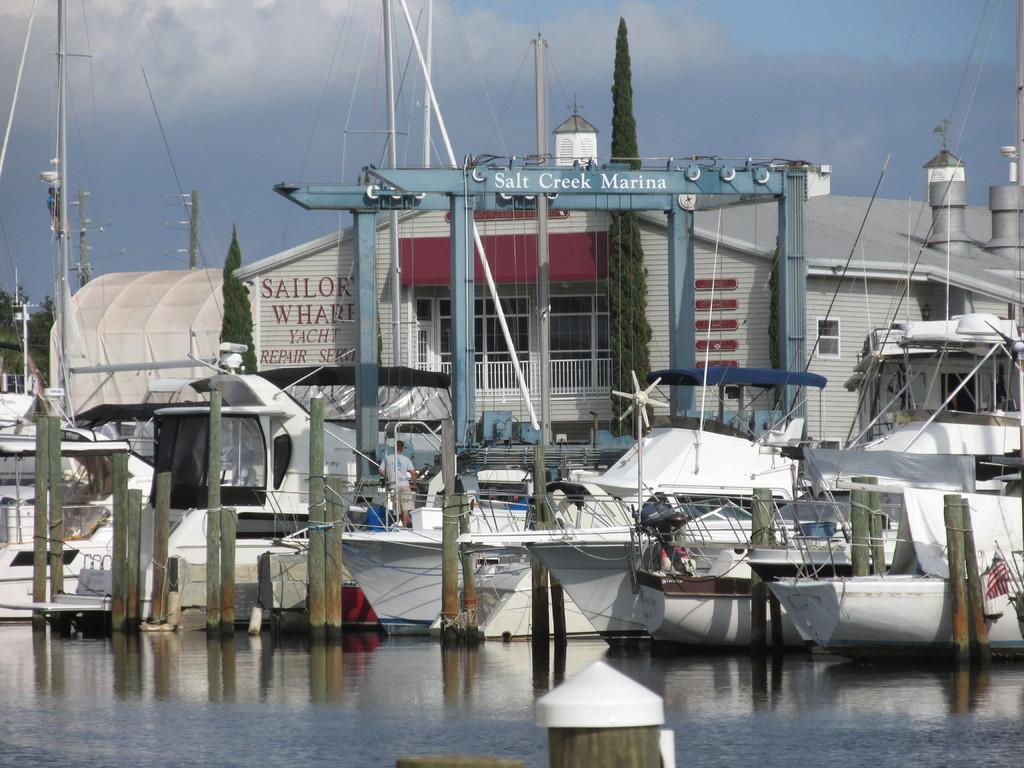<image>
Render a clear and concise summary of the photo. a salt creek marina that is next to some water 